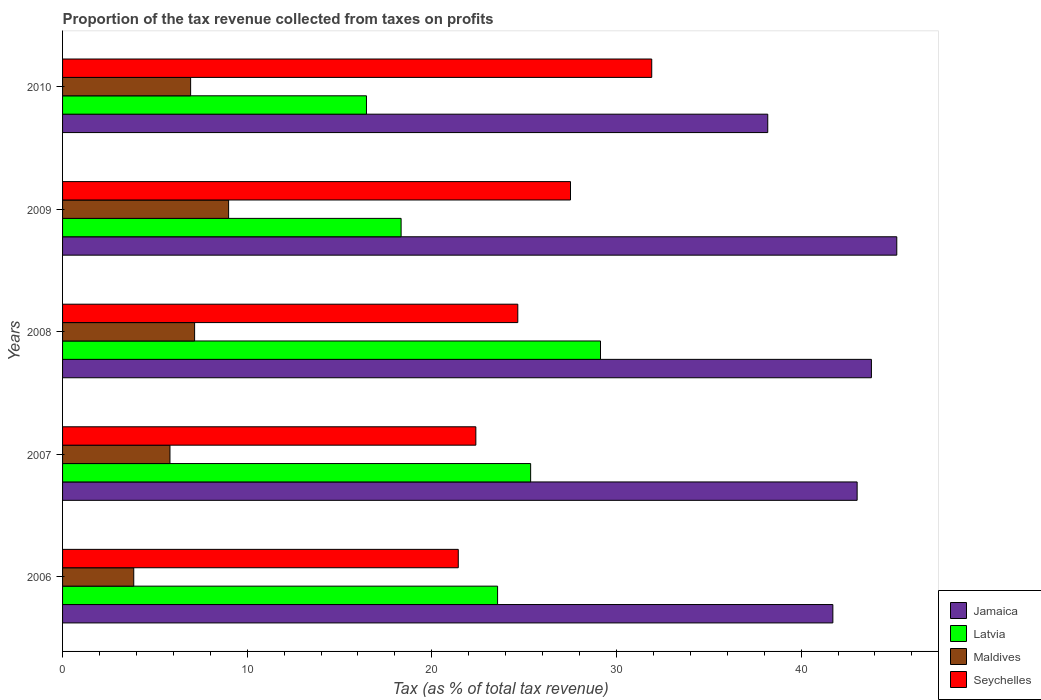How many bars are there on the 4th tick from the top?
Provide a succinct answer. 4. In how many cases, is the number of bars for a given year not equal to the number of legend labels?
Your answer should be compact. 0. What is the proportion of the tax revenue collected in Jamaica in 2008?
Keep it short and to the point. 43.81. Across all years, what is the maximum proportion of the tax revenue collected in Latvia?
Your answer should be compact. 29.14. Across all years, what is the minimum proportion of the tax revenue collected in Maldives?
Give a very brief answer. 3.86. In which year was the proportion of the tax revenue collected in Seychelles minimum?
Your answer should be compact. 2006. What is the total proportion of the tax revenue collected in Maldives in the graph?
Offer a very short reply. 32.75. What is the difference between the proportion of the tax revenue collected in Jamaica in 2009 and that in 2010?
Your answer should be compact. 6.99. What is the difference between the proportion of the tax revenue collected in Latvia in 2010 and the proportion of the tax revenue collected in Jamaica in 2009?
Give a very brief answer. -28.72. What is the average proportion of the tax revenue collected in Jamaica per year?
Keep it short and to the point. 42.39. In the year 2008, what is the difference between the proportion of the tax revenue collected in Seychelles and proportion of the tax revenue collected in Maldives?
Provide a short and direct response. 17.5. What is the ratio of the proportion of the tax revenue collected in Latvia in 2008 to that in 2009?
Your answer should be very brief. 1.59. Is the proportion of the tax revenue collected in Jamaica in 2009 less than that in 2010?
Keep it short and to the point. No. Is the difference between the proportion of the tax revenue collected in Seychelles in 2008 and 2010 greater than the difference between the proportion of the tax revenue collected in Maldives in 2008 and 2010?
Your response must be concise. No. What is the difference between the highest and the second highest proportion of the tax revenue collected in Jamaica?
Your response must be concise. 1.37. What is the difference between the highest and the lowest proportion of the tax revenue collected in Seychelles?
Your answer should be compact. 10.48. Is it the case that in every year, the sum of the proportion of the tax revenue collected in Latvia and proportion of the tax revenue collected in Seychelles is greater than the sum of proportion of the tax revenue collected in Maldives and proportion of the tax revenue collected in Jamaica?
Keep it short and to the point. Yes. What does the 2nd bar from the top in 2009 represents?
Keep it short and to the point. Maldives. What does the 4th bar from the bottom in 2010 represents?
Offer a terse response. Seychelles. How many bars are there?
Offer a very short reply. 20. Are all the bars in the graph horizontal?
Provide a short and direct response. Yes. How many years are there in the graph?
Provide a succinct answer. 5. Does the graph contain any zero values?
Give a very brief answer. No. What is the title of the graph?
Your response must be concise. Proportion of the tax revenue collected from taxes on profits. What is the label or title of the X-axis?
Offer a very short reply. Tax (as % of total tax revenue). What is the label or title of the Y-axis?
Offer a terse response. Years. What is the Tax (as % of total tax revenue) of Jamaica in 2006?
Offer a very short reply. 41.72. What is the Tax (as % of total tax revenue) of Latvia in 2006?
Your answer should be very brief. 23.56. What is the Tax (as % of total tax revenue) of Maldives in 2006?
Your answer should be compact. 3.86. What is the Tax (as % of total tax revenue) in Seychelles in 2006?
Keep it short and to the point. 21.43. What is the Tax (as % of total tax revenue) in Jamaica in 2007?
Keep it short and to the point. 43.04. What is the Tax (as % of total tax revenue) in Latvia in 2007?
Give a very brief answer. 25.35. What is the Tax (as % of total tax revenue) in Maldives in 2007?
Provide a short and direct response. 5.82. What is the Tax (as % of total tax revenue) in Seychelles in 2007?
Offer a terse response. 22.38. What is the Tax (as % of total tax revenue) in Jamaica in 2008?
Your answer should be very brief. 43.81. What is the Tax (as % of total tax revenue) of Latvia in 2008?
Provide a succinct answer. 29.14. What is the Tax (as % of total tax revenue) of Maldives in 2008?
Your response must be concise. 7.15. What is the Tax (as % of total tax revenue) of Seychelles in 2008?
Give a very brief answer. 24.66. What is the Tax (as % of total tax revenue) of Jamaica in 2009?
Keep it short and to the point. 45.18. What is the Tax (as % of total tax revenue) of Latvia in 2009?
Ensure brevity in your answer.  18.34. What is the Tax (as % of total tax revenue) in Maldives in 2009?
Keep it short and to the point. 8.99. What is the Tax (as % of total tax revenue) in Seychelles in 2009?
Your answer should be very brief. 27.51. What is the Tax (as % of total tax revenue) in Jamaica in 2010?
Offer a very short reply. 38.2. What is the Tax (as % of total tax revenue) of Latvia in 2010?
Make the answer very short. 16.46. What is the Tax (as % of total tax revenue) in Maldives in 2010?
Your answer should be very brief. 6.94. What is the Tax (as % of total tax revenue) of Seychelles in 2010?
Your answer should be very brief. 31.91. Across all years, what is the maximum Tax (as % of total tax revenue) of Jamaica?
Keep it short and to the point. 45.18. Across all years, what is the maximum Tax (as % of total tax revenue) of Latvia?
Offer a very short reply. 29.14. Across all years, what is the maximum Tax (as % of total tax revenue) in Maldives?
Your answer should be very brief. 8.99. Across all years, what is the maximum Tax (as % of total tax revenue) in Seychelles?
Offer a terse response. 31.91. Across all years, what is the minimum Tax (as % of total tax revenue) of Jamaica?
Offer a terse response. 38.2. Across all years, what is the minimum Tax (as % of total tax revenue) of Latvia?
Offer a terse response. 16.46. Across all years, what is the minimum Tax (as % of total tax revenue) in Maldives?
Keep it short and to the point. 3.86. Across all years, what is the minimum Tax (as % of total tax revenue) in Seychelles?
Keep it short and to the point. 21.43. What is the total Tax (as % of total tax revenue) in Jamaica in the graph?
Offer a terse response. 211.95. What is the total Tax (as % of total tax revenue) of Latvia in the graph?
Your response must be concise. 112.85. What is the total Tax (as % of total tax revenue) of Maldives in the graph?
Give a very brief answer. 32.75. What is the total Tax (as % of total tax revenue) in Seychelles in the graph?
Provide a succinct answer. 127.9. What is the difference between the Tax (as % of total tax revenue) in Jamaica in 2006 and that in 2007?
Provide a succinct answer. -1.31. What is the difference between the Tax (as % of total tax revenue) of Latvia in 2006 and that in 2007?
Your answer should be very brief. -1.79. What is the difference between the Tax (as % of total tax revenue) in Maldives in 2006 and that in 2007?
Your answer should be very brief. -1.96. What is the difference between the Tax (as % of total tax revenue) in Seychelles in 2006 and that in 2007?
Make the answer very short. -0.95. What is the difference between the Tax (as % of total tax revenue) in Jamaica in 2006 and that in 2008?
Give a very brief answer. -2.09. What is the difference between the Tax (as % of total tax revenue) in Latvia in 2006 and that in 2008?
Your response must be concise. -5.57. What is the difference between the Tax (as % of total tax revenue) of Maldives in 2006 and that in 2008?
Keep it short and to the point. -3.3. What is the difference between the Tax (as % of total tax revenue) in Seychelles in 2006 and that in 2008?
Offer a very short reply. -3.22. What is the difference between the Tax (as % of total tax revenue) in Jamaica in 2006 and that in 2009?
Your answer should be compact. -3.46. What is the difference between the Tax (as % of total tax revenue) of Latvia in 2006 and that in 2009?
Offer a very short reply. 5.22. What is the difference between the Tax (as % of total tax revenue) in Maldives in 2006 and that in 2009?
Offer a terse response. -5.14. What is the difference between the Tax (as % of total tax revenue) of Seychelles in 2006 and that in 2009?
Your answer should be compact. -6.08. What is the difference between the Tax (as % of total tax revenue) in Jamaica in 2006 and that in 2010?
Your answer should be very brief. 3.53. What is the difference between the Tax (as % of total tax revenue) in Latvia in 2006 and that in 2010?
Provide a succinct answer. 7.1. What is the difference between the Tax (as % of total tax revenue) of Maldives in 2006 and that in 2010?
Ensure brevity in your answer.  -3.08. What is the difference between the Tax (as % of total tax revenue) of Seychelles in 2006 and that in 2010?
Your answer should be very brief. -10.48. What is the difference between the Tax (as % of total tax revenue) of Jamaica in 2007 and that in 2008?
Make the answer very short. -0.77. What is the difference between the Tax (as % of total tax revenue) of Latvia in 2007 and that in 2008?
Your answer should be very brief. -3.78. What is the difference between the Tax (as % of total tax revenue) in Maldives in 2007 and that in 2008?
Provide a short and direct response. -1.33. What is the difference between the Tax (as % of total tax revenue) of Seychelles in 2007 and that in 2008?
Offer a very short reply. -2.27. What is the difference between the Tax (as % of total tax revenue) in Jamaica in 2007 and that in 2009?
Give a very brief answer. -2.15. What is the difference between the Tax (as % of total tax revenue) of Latvia in 2007 and that in 2009?
Give a very brief answer. 7.01. What is the difference between the Tax (as % of total tax revenue) in Maldives in 2007 and that in 2009?
Keep it short and to the point. -3.18. What is the difference between the Tax (as % of total tax revenue) of Seychelles in 2007 and that in 2009?
Make the answer very short. -5.13. What is the difference between the Tax (as % of total tax revenue) of Jamaica in 2007 and that in 2010?
Offer a terse response. 4.84. What is the difference between the Tax (as % of total tax revenue) in Latvia in 2007 and that in 2010?
Your response must be concise. 8.89. What is the difference between the Tax (as % of total tax revenue) in Maldives in 2007 and that in 2010?
Your answer should be very brief. -1.12. What is the difference between the Tax (as % of total tax revenue) of Seychelles in 2007 and that in 2010?
Keep it short and to the point. -9.53. What is the difference between the Tax (as % of total tax revenue) of Jamaica in 2008 and that in 2009?
Give a very brief answer. -1.37. What is the difference between the Tax (as % of total tax revenue) in Latvia in 2008 and that in 2009?
Provide a short and direct response. 10.8. What is the difference between the Tax (as % of total tax revenue) of Maldives in 2008 and that in 2009?
Keep it short and to the point. -1.84. What is the difference between the Tax (as % of total tax revenue) of Seychelles in 2008 and that in 2009?
Provide a short and direct response. -2.85. What is the difference between the Tax (as % of total tax revenue) in Jamaica in 2008 and that in 2010?
Give a very brief answer. 5.61. What is the difference between the Tax (as % of total tax revenue) of Latvia in 2008 and that in 2010?
Offer a very short reply. 12.68. What is the difference between the Tax (as % of total tax revenue) in Maldives in 2008 and that in 2010?
Give a very brief answer. 0.22. What is the difference between the Tax (as % of total tax revenue) of Seychelles in 2008 and that in 2010?
Make the answer very short. -7.25. What is the difference between the Tax (as % of total tax revenue) of Jamaica in 2009 and that in 2010?
Give a very brief answer. 6.99. What is the difference between the Tax (as % of total tax revenue) in Latvia in 2009 and that in 2010?
Ensure brevity in your answer.  1.88. What is the difference between the Tax (as % of total tax revenue) in Maldives in 2009 and that in 2010?
Give a very brief answer. 2.06. What is the difference between the Tax (as % of total tax revenue) in Jamaica in 2006 and the Tax (as % of total tax revenue) in Latvia in 2007?
Provide a succinct answer. 16.37. What is the difference between the Tax (as % of total tax revenue) in Jamaica in 2006 and the Tax (as % of total tax revenue) in Maldives in 2007?
Provide a short and direct response. 35.9. What is the difference between the Tax (as % of total tax revenue) in Jamaica in 2006 and the Tax (as % of total tax revenue) in Seychelles in 2007?
Your answer should be compact. 19.34. What is the difference between the Tax (as % of total tax revenue) in Latvia in 2006 and the Tax (as % of total tax revenue) in Maldives in 2007?
Provide a short and direct response. 17.74. What is the difference between the Tax (as % of total tax revenue) in Latvia in 2006 and the Tax (as % of total tax revenue) in Seychelles in 2007?
Give a very brief answer. 1.18. What is the difference between the Tax (as % of total tax revenue) in Maldives in 2006 and the Tax (as % of total tax revenue) in Seychelles in 2007?
Ensure brevity in your answer.  -18.53. What is the difference between the Tax (as % of total tax revenue) in Jamaica in 2006 and the Tax (as % of total tax revenue) in Latvia in 2008?
Offer a very short reply. 12.59. What is the difference between the Tax (as % of total tax revenue) in Jamaica in 2006 and the Tax (as % of total tax revenue) in Maldives in 2008?
Make the answer very short. 34.57. What is the difference between the Tax (as % of total tax revenue) in Jamaica in 2006 and the Tax (as % of total tax revenue) in Seychelles in 2008?
Give a very brief answer. 17.06. What is the difference between the Tax (as % of total tax revenue) of Latvia in 2006 and the Tax (as % of total tax revenue) of Maldives in 2008?
Offer a very short reply. 16.41. What is the difference between the Tax (as % of total tax revenue) in Latvia in 2006 and the Tax (as % of total tax revenue) in Seychelles in 2008?
Make the answer very short. -1.09. What is the difference between the Tax (as % of total tax revenue) of Maldives in 2006 and the Tax (as % of total tax revenue) of Seychelles in 2008?
Offer a very short reply. -20.8. What is the difference between the Tax (as % of total tax revenue) of Jamaica in 2006 and the Tax (as % of total tax revenue) of Latvia in 2009?
Your answer should be compact. 23.38. What is the difference between the Tax (as % of total tax revenue) in Jamaica in 2006 and the Tax (as % of total tax revenue) in Maldives in 2009?
Offer a terse response. 32.73. What is the difference between the Tax (as % of total tax revenue) in Jamaica in 2006 and the Tax (as % of total tax revenue) in Seychelles in 2009?
Ensure brevity in your answer.  14.21. What is the difference between the Tax (as % of total tax revenue) of Latvia in 2006 and the Tax (as % of total tax revenue) of Maldives in 2009?
Ensure brevity in your answer.  14.57. What is the difference between the Tax (as % of total tax revenue) of Latvia in 2006 and the Tax (as % of total tax revenue) of Seychelles in 2009?
Keep it short and to the point. -3.95. What is the difference between the Tax (as % of total tax revenue) of Maldives in 2006 and the Tax (as % of total tax revenue) of Seychelles in 2009?
Provide a succinct answer. -23.66. What is the difference between the Tax (as % of total tax revenue) in Jamaica in 2006 and the Tax (as % of total tax revenue) in Latvia in 2010?
Make the answer very short. 25.26. What is the difference between the Tax (as % of total tax revenue) of Jamaica in 2006 and the Tax (as % of total tax revenue) of Maldives in 2010?
Ensure brevity in your answer.  34.79. What is the difference between the Tax (as % of total tax revenue) of Jamaica in 2006 and the Tax (as % of total tax revenue) of Seychelles in 2010?
Give a very brief answer. 9.81. What is the difference between the Tax (as % of total tax revenue) in Latvia in 2006 and the Tax (as % of total tax revenue) in Maldives in 2010?
Your response must be concise. 16.63. What is the difference between the Tax (as % of total tax revenue) of Latvia in 2006 and the Tax (as % of total tax revenue) of Seychelles in 2010?
Your answer should be very brief. -8.35. What is the difference between the Tax (as % of total tax revenue) of Maldives in 2006 and the Tax (as % of total tax revenue) of Seychelles in 2010?
Offer a terse response. -28.06. What is the difference between the Tax (as % of total tax revenue) in Jamaica in 2007 and the Tax (as % of total tax revenue) in Latvia in 2008?
Your answer should be compact. 13.9. What is the difference between the Tax (as % of total tax revenue) in Jamaica in 2007 and the Tax (as % of total tax revenue) in Maldives in 2008?
Offer a terse response. 35.88. What is the difference between the Tax (as % of total tax revenue) in Jamaica in 2007 and the Tax (as % of total tax revenue) in Seychelles in 2008?
Ensure brevity in your answer.  18.38. What is the difference between the Tax (as % of total tax revenue) of Latvia in 2007 and the Tax (as % of total tax revenue) of Maldives in 2008?
Your answer should be very brief. 18.2. What is the difference between the Tax (as % of total tax revenue) of Latvia in 2007 and the Tax (as % of total tax revenue) of Seychelles in 2008?
Your answer should be very brief. 0.69. What is the difference between the Tax (as % of total tax revenue) in Maldives in 2007 and the Tax (as % of total tax revenue) in Seychelles in 2008?
Your answer should be very brief. -18.84. What is the difference between the Tax (as % of total tax revenue) of Jamaica in 2007 and the Tax (as % of total tax revenue) of Latvia in 2009?
Ensure brevity in your answer.  24.7. What is the difference between the Tax (as % of total tax revenue) in Jamaica in 2007 and the Tax (as % of total tax revenue) in Maldives in 2009?
Your answer should be compact. 34.04. What is the difference between the Tax (as % of total tax revenue) of Jamaica in 2007 and the Tax (as % of total tax revenue) of Seychelles in 2009?
Keep it short and to the point. 15.53. What is the difference between the Tax (as % of total tax revenue) of Latvia in 2007 and the Tax (as % of total tax revenue) of Maldives in 2009?
Your answer should be compact. 16.36. What is the difference between the Tax (as % of total tax revenue) in Latvia in 2007 and the Tax (as % of total tax revenue) in Seychelles in 2009?
Your response must be concise. -2.16. What is the difference between the Tax (as % of total tax revenue) in Maldives in 2007 and the Tax (as % of total tax revenue) in Seychelles in 2009?
Provide a short and direct response. -21.69. What is the difference between the Tax (as % of total tax revenue) in Jamaica in 2007 and the Tax (as % of total tax revenue) in Latvia in 2010?
Make the answer very short. 26.58. What is the difference between the Tax (as % of total tax revenue) of Jamaica in 2007 and the Tax (as % of total tax revenue) of Maldives in 2010?
Your response must be concise. 36.1. What is the difference between the Tax (as % of total tax revenue) in Jamaica in 2007 and the Tax (as % of total tax revenue) in Seychelles in 2010?
Provide a succinct answer. 11.12. What is the difference between the Tax (as % of total tax revenue) in Latvia in 2007 and the Tax (as % of total tax revenue) in Maldives in 2010?
Offer a terse response. 18.42. What is the difference between the Tax (as % of total tax revenue) in Latvia in 2007 and the Tax (as % of total tax revenue) in Seychelles in 2010?
Your response must be concise. -6.56. What is the difference between the Tax (as % of total tax revenue) in Maldives in 2007 and the Tax (as % of total tax revenue) in Seychelles in 2010?
Keep it short and to the point. -26.09. What is the difference between the Tax (as % of total tax revenue) of Jamaica in 2008 and the Tax (as % of total tax revenue) of Latvia in 2009?
Offer a very short reply. 25.47. What is the difference between the Tax (as % of total tax revenue) of Jamaica in 2008 and the Tax (as % of total tax revenue) of Maldives in 2009?
Your answer should be very brief. 34.82. What is the difference between the Tax (as % of total tax revenue) in Jamaica in 2008 and the Tax (as % of total tax revenue) in Seychelles in 2009?
Keep it short and to the point. 16.3. What is the difference between the Tax (as % of total tax revenue) in Latvia in 2008 and the Tax (as % of total tax revenue) in Maldives in 2009?
Your response must be concise. 20.14. What is the difference between the Tax (as % of total tax revenue) of Latvia in 2008 and the Tax (as % of total tax revenue) of Seychelles in 2009?
Offer a terse response. 1.62. What is the difference between the Tax (as % of total tax revenue) of Maldives in 2008 and the Tax (as % of total tax revenue) of Seychelles in 2009?
Keep it short and to the point. -20.36. What is the difference between the Tax (as % of total tax revenue) in Jamaica in 2008 and the Tax (as % of total tax revenue) in Latvia in 2010?
Give a very brief answer. 27.35. What is the difference between the Tax (as % of total tax revenue) of Jamaica in 2008 and the Tax (as % of total tax revenue) of Maldives in 2010?
Give a very brief answer. 36.87. What is the difference between the Tax (as % of total tax revenue) of Jamaica in 2008 and the Tax (as % of total tax revenue) of Seychelles in 2010?
Your answer should be very brief. 11.9. What is the difference between the Tax (as % of total tax revenue) in Latvia in 2008 and the Tax (as % of total tax revenue) in Maldives in 2010?
Offer a terse response. 22.2. What is the difference between the Tax (as % of total tax revenue) in Latvia in 2008 and the Tax (as % of total tax revenue) in Seychelles in 2010?
Your response must be concise. -2.78. What is the difference between the Tax (as % of total tax revenue) of Maldives in 2008 and the Tax (as % of total tax revenue) of Seychelles in 2010?
Your response must be concise. -24.76. What is the difference between the Tax (as % of total tax revenue) of Jamaica in 2009 and the Tax (as % of total tax revenue) of Latvia in 2010?
Offer a terse response. 28.72. What is the difference between the Tax (as % of total tax revenue) of Jamaica in 2009 and the Tax (as % of total tax revenue) of Maldives in 2010?
Provide a succinct answer. 38.25. What is the difference between the Tax (as % of total tax revenue) of Jamaica in 2009 and the Tax (as % of total tax revenue) of Seychelles in 2010?
Ensure brevity in your answer.  13.27. What is the difference between the Tax (as % of total tax revenue) in Latvia in 2009 and the Tax (as % of total tax revenue) in Maldives in 2010?
Provide a succinct answer. 11.4. What is the difference between the Tax (as % of total tax revenue) of Latvia in 2009 and the Tax (as % of total tax revenue) of Seychelles in 2010?
Your response must be concise. -13.57. What is the difference between the Tax (as % of total tax revenue) in Maldives in 2009 and the Tax (as % of total tax revenue) in Seychelles in 2010?
Your answer should be compact. -22.92. What is the average Tax (as % of total tax revenue) of Jamaica per year?
Your response must be concise. 42.39. What is the average Tax (as % of total tax revenue) in Latvia per year?
Make the answer very short. 22.57. What is the average Tax (as % of total tax revenue) of Maldives per year?
Offer a terse response. 6.55. What is the average Tax (as % of total tax revenue) in Seychelles per year?
Your response must be concise. 25.58. In the year 2006, what is the difference between the Tax (as % of total tax revenue) in Jamaica and Tax (as % of total tax revenue) in Latvia?
Provide a succinct answer. 18.16. In the year 2006, what is the difference between the Tax (as % of total tax revenue) in Jamaica and Tax (as % of total tax revenue) in Maldives?
Ensure brevity in your answer.  37.87. In the year 2006, what is the difference between the Tax (as % of total tax revenue) in Jamaica and Tax (as % of total tax revenue) in Seychelles?
Offer a very short reply. 20.29. In the year 2006, what is the difference between the Tax (as % of total tax revenue) in Latvia and Tax (as % of total tax revenue) in Maldives?
Provide a succinct answer. 19.71. In the year 2006, what is the difference between the Tax (as % of total tax revenue) in Latvia and Tax (as % of total tax revenue) in Seychelles?
Keep it short and to the point. 2.13. In the year 2006, what is the difference between the Tax (as % of total tax revenue) of Maldives and Tax (as % of total tax revenue) of Seychelles?
Provide a short and direct response. -17.58. In the year 2007, what is the difference between the Tax (as % of total tax revenue) of Jamaica and Tax (as % of total tax revenue) of Latvia?
Give a very brief answer. 17.68. In the year 2007, what is the difference between the Tax (as % of total tax revenue) of Jamaica and Tax (as % of total tax revenue) of Maldives?
Your answer should be compact. 37.22. In the year 2007, what is the difference between the Tax (as % of total tax revenue) of Jamaica and Tax (as % of total tax revenue) of Seychelles?
Offer a terse response. 20.65. In the year 2007, what is the difference between the Tax (as % of total tax revenue) of Latvia and Tax (as % of total tax revenue) of Maldives?
Provide a short and direct response. 19.53. In the year 2007, what is the difference between the Tax (as % of total tax revenue) of Latvia and Tax (as % of total tax revenue) of Seychelles?
Offer a very short reply. 2.97. In the year 2007, what is the difference between the Tax (as % of total tax revenue) in Maldives and Tax (as % of total tax revenue) in Seychelles?
Keep it short and to the point. -16.57. In the year 2008, what is the difference between the Tax (as % of total tax revenue) in Jamaica and Tax (as % of total tax revenue) in Latvia?
Give a very brief answer. 14.67. In the year 2008, what is the difference between the Tax (as % of total tax revenue) in Jamaica and Tax (as % of total tax revenue) in Maldives?
Make the answer very short. 36.66. In the year 2008, what is the difference between the Tax (as % of total tax revenue) of Jamaica and Tax (as % of total tax revenue) of Seychelles?
Your response must be concise. 19.15. In the year 2008, what is the difference between the Tax (as % of total tax revenue) of Latvia and Tax (as % of total tax revenue) of Maldives?
Your answer should be compact. 21.98. In the year 2008, what is the difference between the Tax (as % of total tax revenue) of Latvia and Tax (as % of total tax revenue) of Seychelles?
Provide a short and direct response. 4.48. In the year 2008, what is the difference between the Tax (as % of total tax revenue) in Maldives and Tax (as % of total tax revenue) in Seychelles?
Keep it short and to the point. -17.5. In the year 2009, what is the difference between the Tax (as % of total tax revenue) in Jamaica and Tax (as % of total tax revenue) in Latvia?
Ensure brevity in your answer.  26.85. In the year 2009, what is the difference between the Tax (as % of total tax revenue) in Jamaica and Tax (as % of total tax revenue) in Maldives?
Your answer should be compact. 36.19. In the year 2009, what is the difference between the Tax (as % of total tax revenue) of Jamaica and Tax (as % of total tax revenue) of Seychelles?
Ensure brevity in your answer.  17.67. In the year 2009, what is the difference between the Tax (as % of total tax revenue) in Latvia and Tax (as % of total tax revenue) in Maldives?
Keep it short and to the point. 9.34. In the year 2009, what is the difference between the Tax (as % of total tax revenue) in Latvia and Tax (as % of total tax revenue) in Seychelles?
Ensure brevity in your answer.  -9.17. In the year 2009, what is the difference between the Tax (as % of total tax revenue) in Maldives and Tax (as % of total tax revenue) in Seychelles?
Provide a short and direct response. -18.52. In the year 2010, what is the difference between the Tax (as % of total tax revenue) in Jamaica and Tax (as % of total tax revenue) in Latvia?
Ensure brevity in your answer.  21.73. In the year 2010, what is the difference between the Tax (as % of total tax revenue) in Jamaica and Tax (as % of total tax revenue) in Maldives?
Keep it short and to the point. 31.26. In the year 2010, what is the difference between the Tax (as % of total tax revenue) of Jamaica and Tax (as % of total tax revenue) of Seychelles?
Make the answer very short. 6.28. In the year 2010, what is the difference between the Tax (as % of total tax revenue) of Latvia and Tax (as % of total tax revenue) of Maldives?
Ensure brevity in your answer.  9.52. In the year 2010, what is the difference between the Tax (as % of total tax revenue) in Latvia and Tax (as % of total tax revenue) in Seychelles?
Ensure brevity in your answer.  -15.45. In the year 2010, what is the difference between the Tax (as % of total tax revenue) in Maldives and Tax (as % of total tax revenue) in Seychelles?
Offer a terse response. -24.98. What is the ratio of the Tax (as % of total tax revenue) in Jamaica in 2006 to that in 2007?
Offer a terse response. 0.97. What is the ratio of the Tax (as % of total tax revenue) of Latvia in 2006 to that in 2007?
Offer a very short reply. 0.93. What is the ratio of the Tax (as % of total tax revenue) of Maldives in 2006 to that in 2007?
Make the answer very short. 0.66. What is the ratio of the Tax (as % of total tax revenue) of Seychelles in 2006 to that in 2007?
Your response must be concise. 0.96. What is the ratio of the Tax (as % of total tax revenue) in Jamaica in 2006 to that in 2008?
Offer a very short reply. 0.95. What is the ratio of the Tax (as % of total tax revenue) of Latvia in 2006 to that in 2008?
Keep it short and to the point. 0.81. What is the ratio of the Tax (as % of total tax revenue) in Maldives in 2006 to that in 2008?
Your response must be concise. 0.54. What is the ratio of the Tax (as % of total tax revenue) of Seychelles in 2006 to that in 2008?
Your answer should be compact. 0.87. What is the ratio of the Tax (as % of total tax revenue) of Jamaica in 2006 to that in 2009?
Your answer should be compact. 0.92. What is the ratio of the Tax (as % of total tax revenue) in Latvia in 2006 to that in 2009?
Ensure brevity in your answer.  1.28. What is the ratio of the Tax (as % of total tax revenue) in Maldives in 2006 to that in 2009?
Your response must be concise. 0.43. What is the ratio of the Tax (as % of total tax revenue) in Seychelles in 2006 to that in 2009?
Offer a terse response. 0.78. What is the ratio of the Tax (as % of total tax revenue) of Jamaica in 2006 to that in 2010?
Offer a terse response. 1.09. What is the ratio of the Tax (as % of total tax revenue) of Latvia in 2006 to that in 2010?
Your answer should be very brief. 1.43. What is the ratio of the Tax (as % of total tax revenue) of Maldives in 2006 to that in 2010?
Provide a short and direct response. 0.56. What is the ratio of the Tax (as % of total tax revenue) of Seychelles in 2006 to that in 2010?
Provide a succinct answer. 0.67. What is the ratio of the Tax (as % of total tax revenue) of Jamaica in 2007 to that in 2008?
Your answer should be very brief. 0.98. What is the ratio of the Tax (as % of total tax revenue) in Latvia in 2007 to that in 2008?
Make the answer very short. 0.87. What is the ratio of the Tax (as % of total tax revenue) in Maldives in 2007 to that in 2008?
Keep it short and to the point. 0.81. What is the ratio of the Tax (as % of total tax revenue) in Seychelles in 2007 to that in 2008?
Your response must be concise. 0.91. What is the ratio of the Tax (as % of total tax revenue) in Jamaica in 2007 to that in 2009?
Provide a short and direct response. 0.95. What is the ratio of the Tax (as % of total tax revenue) in Latvia in 2007 to that in 2009?
Offer a terse response. 1.38. What is the ratio of the Tax (as % of total tax revenue) of Maldives in 2007 to that in 2009?
Provide a succinct answer. 0.65. What is the ratio of the Tax (as % of total tax revenue) of Seychelles in 2007 to that in 2009?
Keep it short and to the point. 0.81. What is the ratio of the Tax (as % of total tax revenue) in Jamaica in 2007 to that in 2010?
Make the answer very short. 1.13. What is the ratio of the Tax (as % of total tax revenue) in Latvia in 2007 to that in 2010?
Your answer should be very brief. 1.54. What is the ratio of the Tax (as % of total tax revenue) in Maldives in 2007 to that in 2010?
Your answer should be compact. 0.84. What is the ratio of the Tax (as % of total tax revenue) of Seychelles in 2007 to that in 2010?
Ensure brevity in your answer.  0.7. What is the ratio of the Tax (as % of total tax revenue) in Jamaica in 2008 to that in 2009?
Ensure brevity in your answer.  0.97. What is the ratio of the Tax (as % of total tax revenue) in Latvia in 2008 to that in 2009?
Offer a terse response. 1.59. What is the ratio of the Tax (as % of total tax revenue) of Maldives in 2008 to that in 2009?
Give a very brief answer. 0.8. What is the ratio of the Tax (as % of total tax revenue) of Seychelles in 2008 to that in 2009?
Your response must be concise. 0.9. What is the ratio of the Tax (as % of total tax revenue) of Jamaica in 2008 to that in 2010?
Keep it short and to the point. 1.15. What is the ratio of the Tax (as % of total tax revenue) in Latvia in 2008 to that in 2010?
Your answer should be compact. 1.77. What is the ratio of the Tax (as % of total tax revenue) of Maldives in 2008 to that in 2010?
Ensure brevity in your answer.  1.03. What is the ratio of the Tax (as % of total tax revenue) in Seychelles in 2008 to that in 2010?
Your answer should be compact. 0.77. What is the ratio of the Tax (as % of total tax revenue) of Jamaica in 2009 to that in 2010?
Make the answer very short. 1.18. What is the ratio of the Tax (as % of total tax revenue) of Latvia in 2009 to that in 2010?
Give a very brief answer. 1.11. What is the ratio of the Tax (as % of total tax revenue) of Maldives in 2009 to that in 2010?
Your answer should be compact. 1.3. What is the ratio of the Tax (as % of total tax revenue) in Seychelles in 2009 to that in 2010?
Provide a succinct answer. 0.86. What is the difference between the highest and the second highest Tax (as % of total tax revenue) of Jamaica?
Your answer should be very brief. 1.37. What is the difference between the highest and the second highest Tax (as % of total tax revenue) of Latvia?
Ensure brevity in your answer.  3.78. What is the difference between the highest and the second highest Tax (as % of total tax revenue) of Maldives?
Make the answer very short. 1.84. What is the difference between the highest and the second highest Tax (as % of total tax revenue) in Seychelles?
Give a very brief answer. 4.4. What is the difference between the highest and the lowest Tax (as % of total tax revenue) in Jamaica?
Offer a very short reply. 6.99. What is the difference between the highest and the lowest Tax (as % of total tax revenue) of Latvia?
Offer a terse response. 12.68. What is the difference between the highest and the lowest Tax (as % of total tax revenue) of Maldives?
Provide a succinct answer. 5.14. What is the difference between the highest and the lowest Tax (as % of total tax revenue) in Seychelles?
Offer a very short reply. 10.48. 